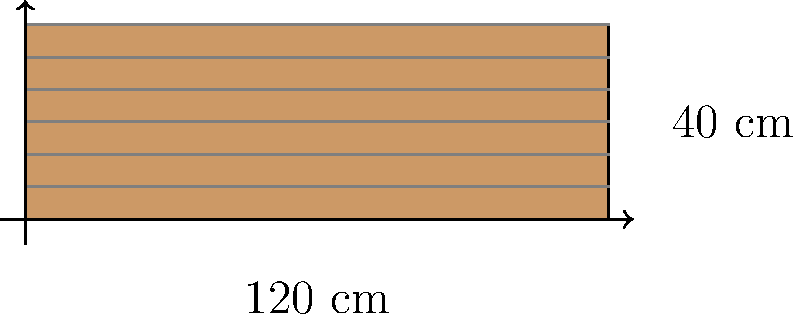You're designing a custom guitar fretboard for a student. The fretboard is rectangular with a length of 120 cm and a width of 40 cm. What is the perimeter of this fretboard in meters? Let's approach this step-by-step:

1) First, recall the formula for the perimeter of a rectangle:
   $$P = 2l + 2w$$
   where $P$ is the perimeter, $l$ is the length, and $w$ is the width.

2) We're given:
   Length $(l) = 120$ cm
   Width $(w) = 40$ cm

3) Let's substitute these values into our formula:
   $$P = 2(120) + 2(40)$$

4) Simplify:
   $$P = 240 + 80 = 320$$ cm

5) The question asks for the answer in meters. We know that:
   1 m = 100 cm

6) So, we need to divide our result by 100:
   $$320 \text{ cm} \div 100 = 3.2 \text{ m}$$

Therefore, the perimeter of the fretboard is 3.2 meters.
Answer: 3.2 m 